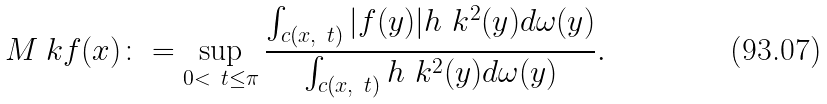<formula> <loc_0><loc_0><loc_500><loc_500>M _ { \ } k f ( x ) \colon = \sup _ { 0 < \ t \leq \pi } \frac { \int _ { c ( x , \ t ) } | f ( y ) | h _ { \ } k ^ { 2 } ( y ) d \omega ( y ) } { \int _ { c ( x , \ t ) } h _ { \ } k ^ { 2 } ( y ) d \omega ( y ) } .</formula> 